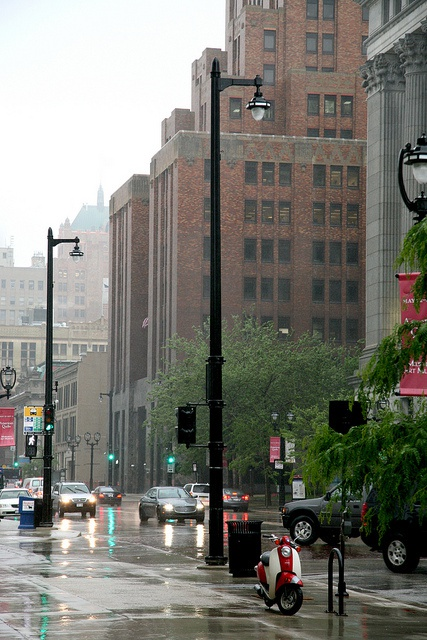Describe the objects in this image and their specific colors. I can see car in lavender, black, gray, darkgreen, and maroon tones, car in lavender, black, gray, darkgreen, and darkgray tones, motorcycle in lavender, black, maroon, gray, and darkgray tones, car in lavender, black, gray, darkgray, and lightgray tones, and car in lavender, darkgray, white, gray, and black tones in this image. 